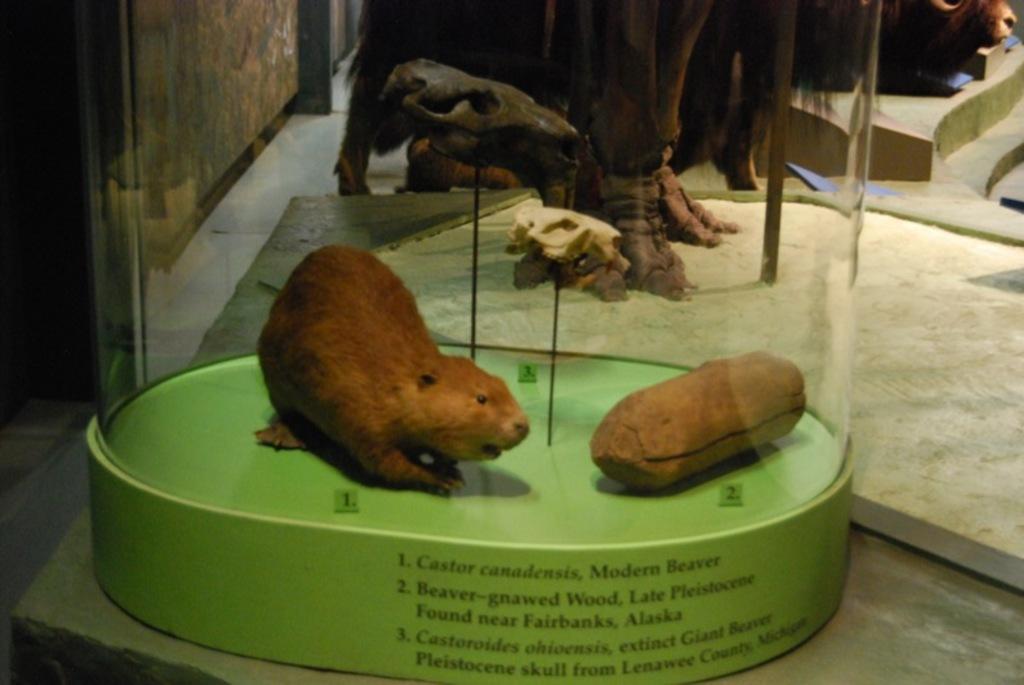In one or two sentences, can you explain what this image depicts? In this image I can see an animal visible on green color box and at the top I can see sculpture ,animals and on the box I can see text 